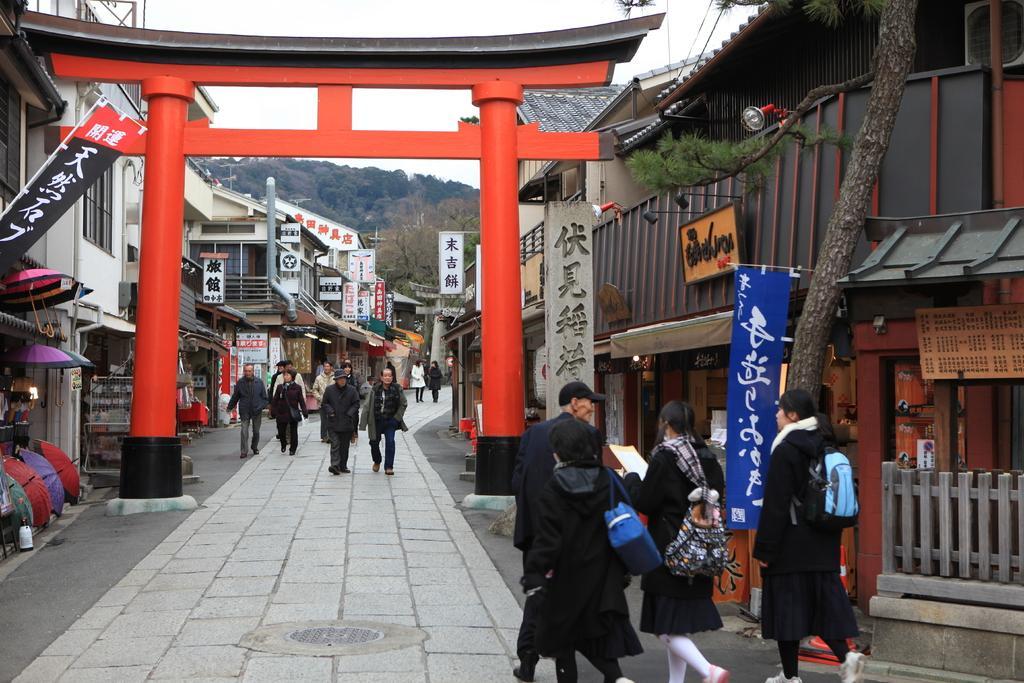Please provide a concise description of this image. In this image we can see an arch with pillars. There are many people. Some are holding bags. On the sides there are many buildings. There are banners with text. And we can see umbrellas. In the background there are trees, hill and sky. 